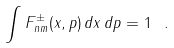<formula> <loc_0><loc_0><loc_500><loc_500>\int F ^ { \pm } _ { n m } ( { x } , { p } ) \, d { x } \, d { p } = 1 \ .</formula> 